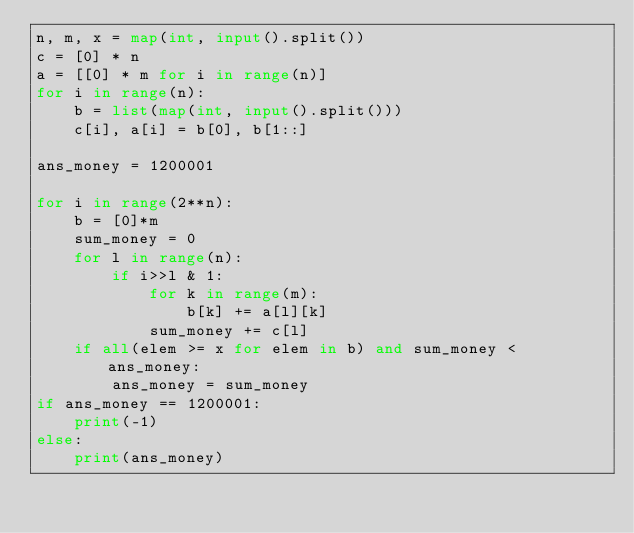Convert code to text. <code><loc_0><loc_0><loc_500><loc_500><_Python_>n, m, x = map(int, input().split())
c = [0] * n
a = [[0] * m for i in range(n)]
for i in range(n):
    b = list(map(int, input().split()))
    c[i], a[i] = b[0], b[1::]

ans_money = 1200001

for i in range(2**n):
    b = [0]*m
    sum_money = 0
    for l in range(n):
        if i>>l & 1:
            for k in range(m):
                b[k] += a[l][k]            
            sum_money += c[l]
    if all(elem >= x for elem in b) and sum_money < ans_money:
        ans_money = sum_money
if ans_money == 1200001:
    print(-1)
else:
    print(ans_money)</code> 